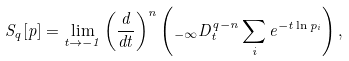Convert formula to latex. <formula><loc_0><loc_0><loc_500><loc_500>S _ { q } [ p ] = \lim _ { t \rightarrow - 1 } \left ( \frac { d } { d t } \right ) ^ { n } \left ( _ { - \infty } D _ { t } ^ { q - n } \sum _ { i } e ^ { - t \ln p _ { i } } \right ) ,</formula> 